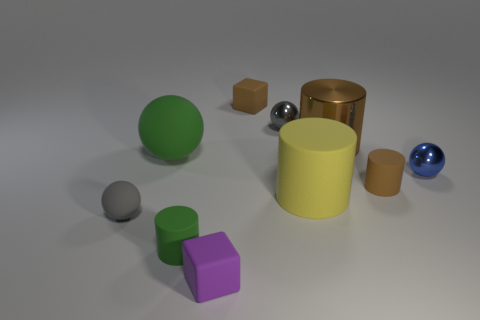What number of other small objects are the same shape as the purple object?
Provide a succinct answer. 1. What size is the gray thing that is made of the same material as the big green ball?
Give a very brief answer. Small. Does the gray shiny object have the same size as the purple matte cube?
Offer a terse response. Yes. Is there a tiny gray metal sphere?
Your answer should be compact. Yes. The thing that is the same color as the big ball is what size?
Offer a terse response. Small. What size is the rubber thing in front of the cylinder left of the rubber block behind the purple thing?
Provide a succinct answer. Small. How many small blue objects are made of the same material as the purple thing?
Your answer should be compact. 0. What number of green rubber balls are the same size as the gray shiny ball?
Your answer should be very brief. 0. What material is the tiny gray object that is on the right side of the rubber thing that is in front of the cylinder in front of the small gray matte object made of?
Ensure brevity in your answer.  Metal. What number of objects are large brown things or small blue metallic things?
Keep it short and to the point. 2. 